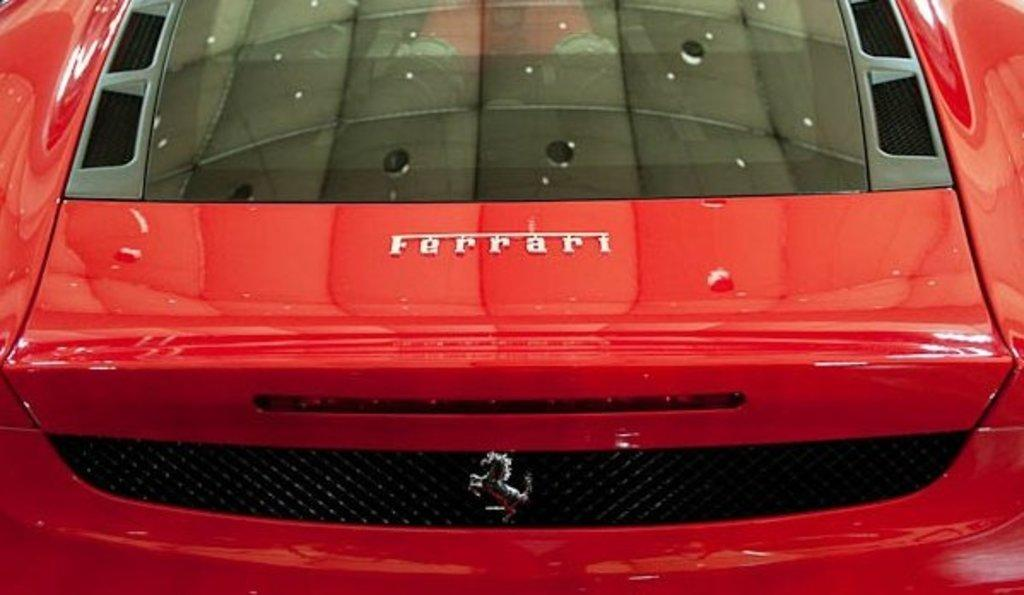What color is the car in the picture? The car in the picture is red. What can be seen on the car? The car has a logo on it. Are there any cobwebs visible on the car in the picture? There is no mention of cobwebs in the provided facts, and therefore we cannot determine if any are present on the car. Can you hear the horn of the car in the picture? The provided facts do not mention any sound, so we cannot determine if the horn can be heard. 